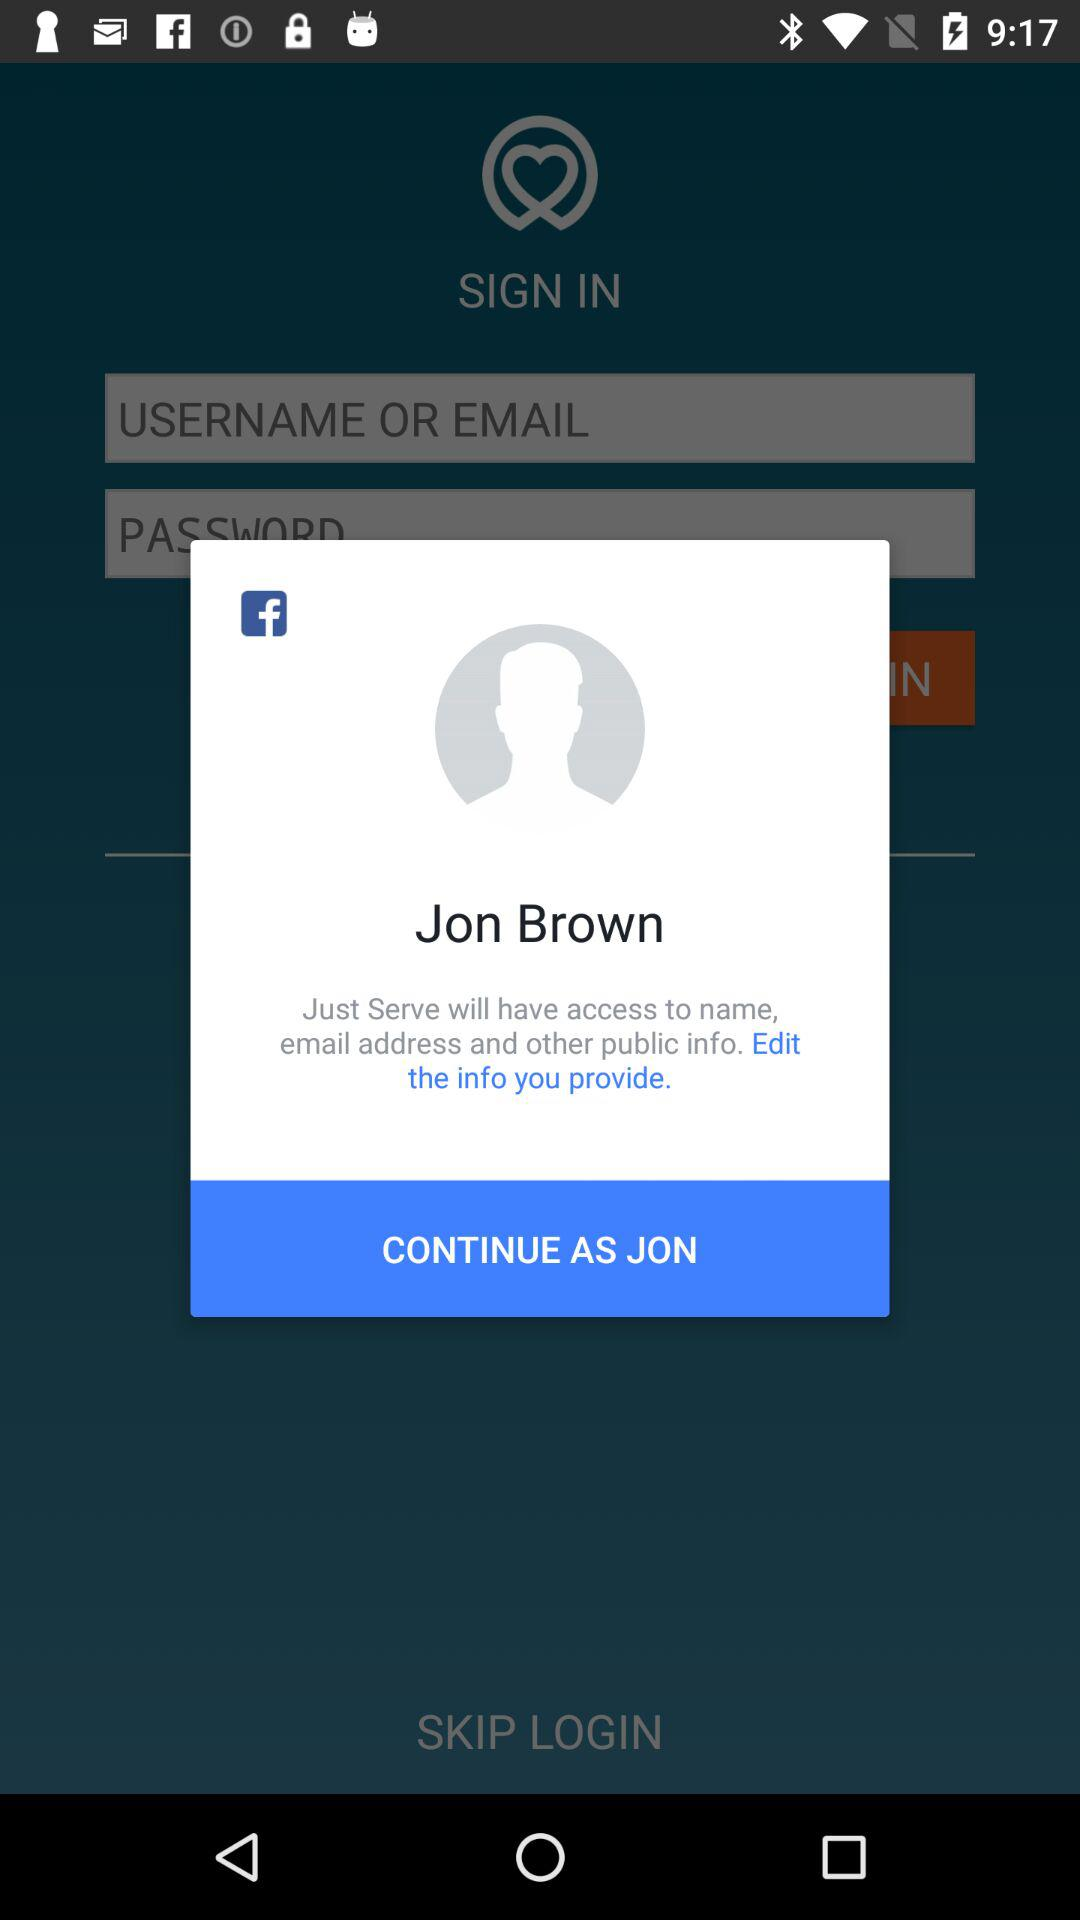What is the name of the user? The name of the user is Jon Brown. 